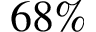Convert formula to latex. <formula><loc_0><loc_0><loc_500><loc_500>6 8 \%</formula> 